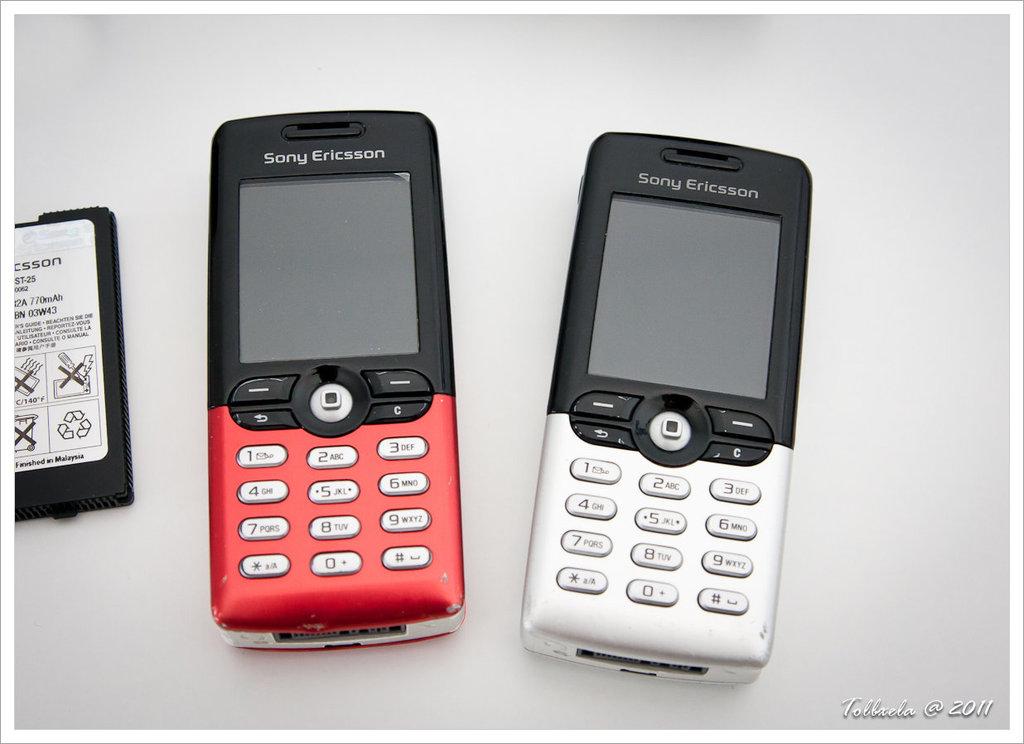What brand of phone are these?
Offer a very short reply. Sony ericsson. Is the battery recyclable?
Offer a very short reply. Yes. 